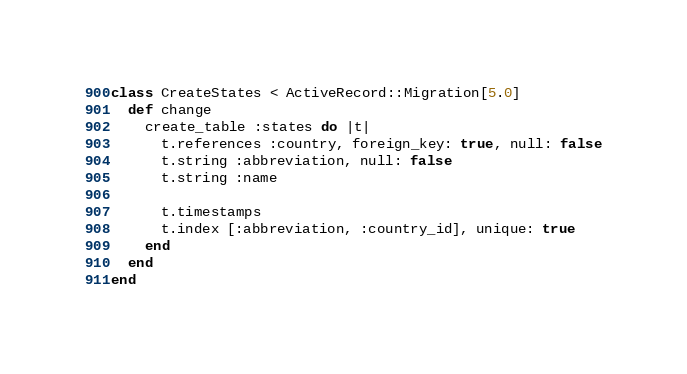Convert code to text. <code><loc_0><loc_0><loc_500><loc_500><_Ruby_>class CreateStates < ActiveRecord::Migration[5.0]
  def change
    create_table :states do |t|
      t.references :country, foreign_key: true, null: false
      t.string :abbreviation, null: false
      t.string :name

      t.timestamps
      t.index [:abbreviation, :country_id], unique: true
    end
  end
end
</code> 